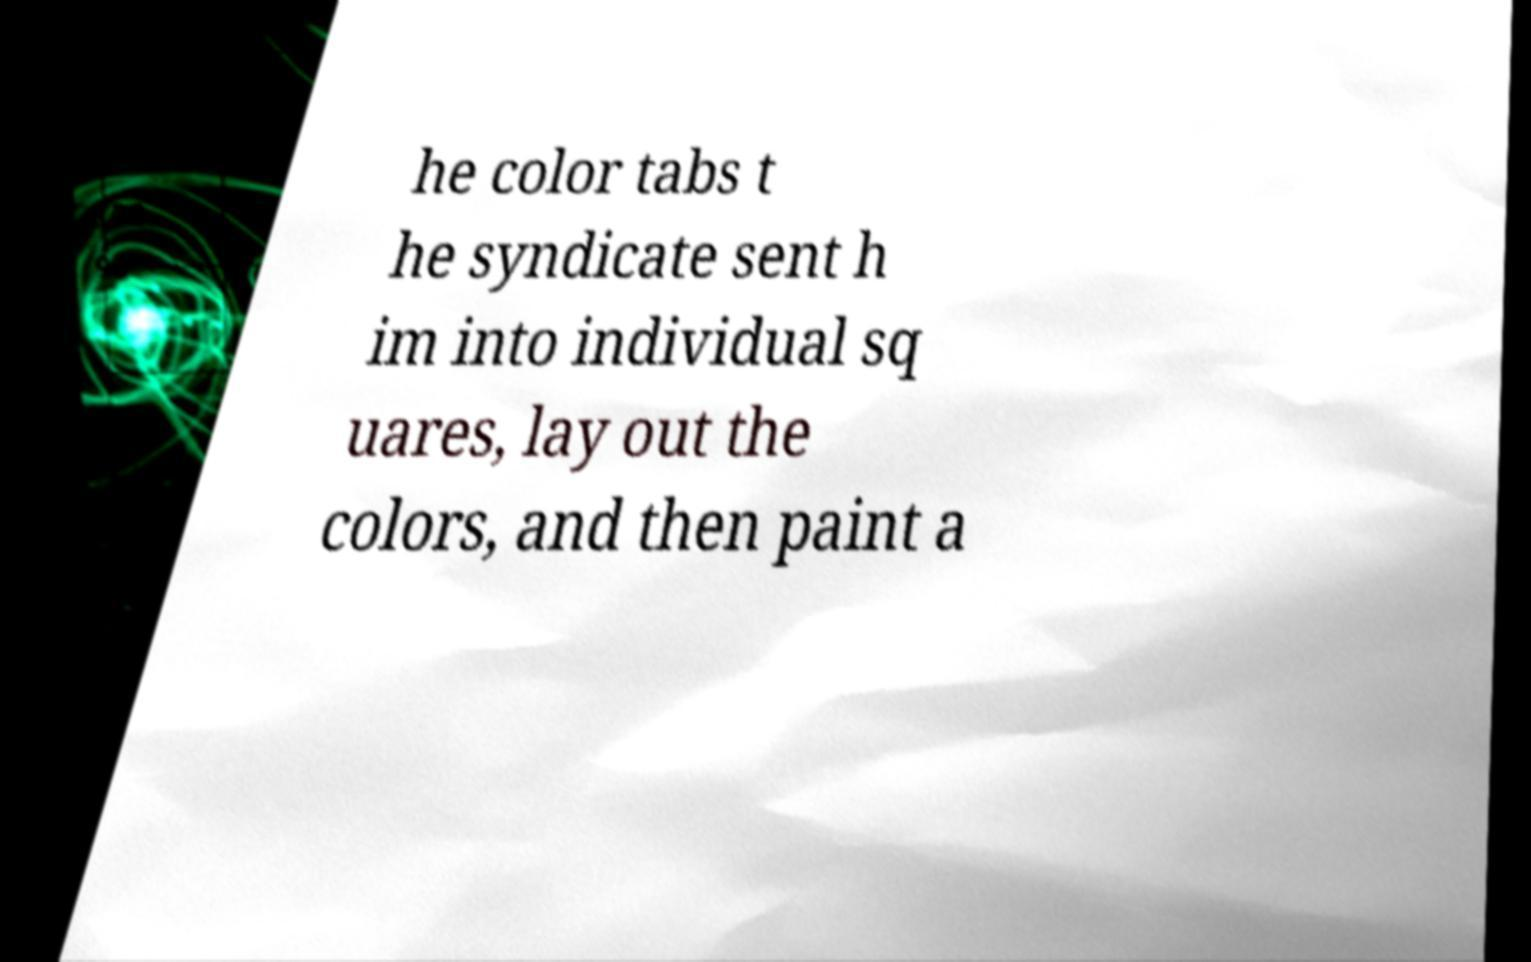Could you extract and type out the text from this image? he color tabs t he syndicate sent h im into individual sq uares, lay out the colors, and then paint a 